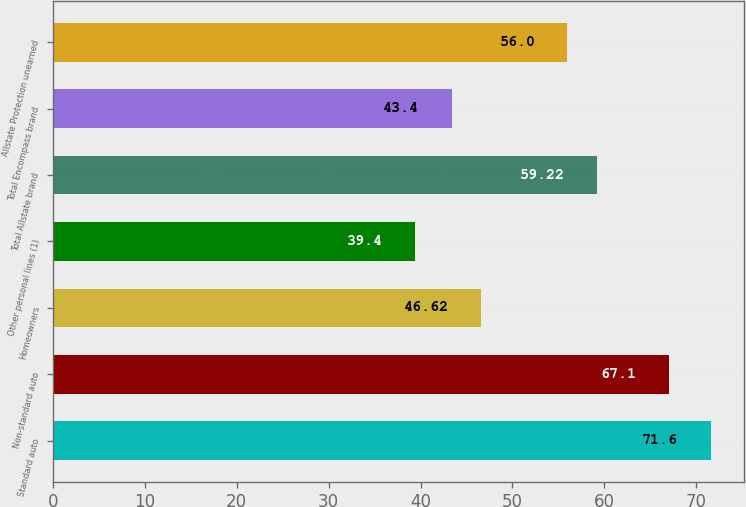Convert chart to OTSL. <chart><loc_0><loc_0><loc_500><loc_500><bar_chart><fcel>Standard auto<fcel>Non-standard auto<fcel>Homeowners<fcel>Other personal lines (1)<fcel>Total Allstate brand<fcel>Total Encompass brand<fcel>Allstate Protection unearned<nl><fcel>71.6<fcel>67.1<fcel>46.62<fcel>39.4<fcel>59.22<fcel>43.4<fcel>56<nl></chart> 